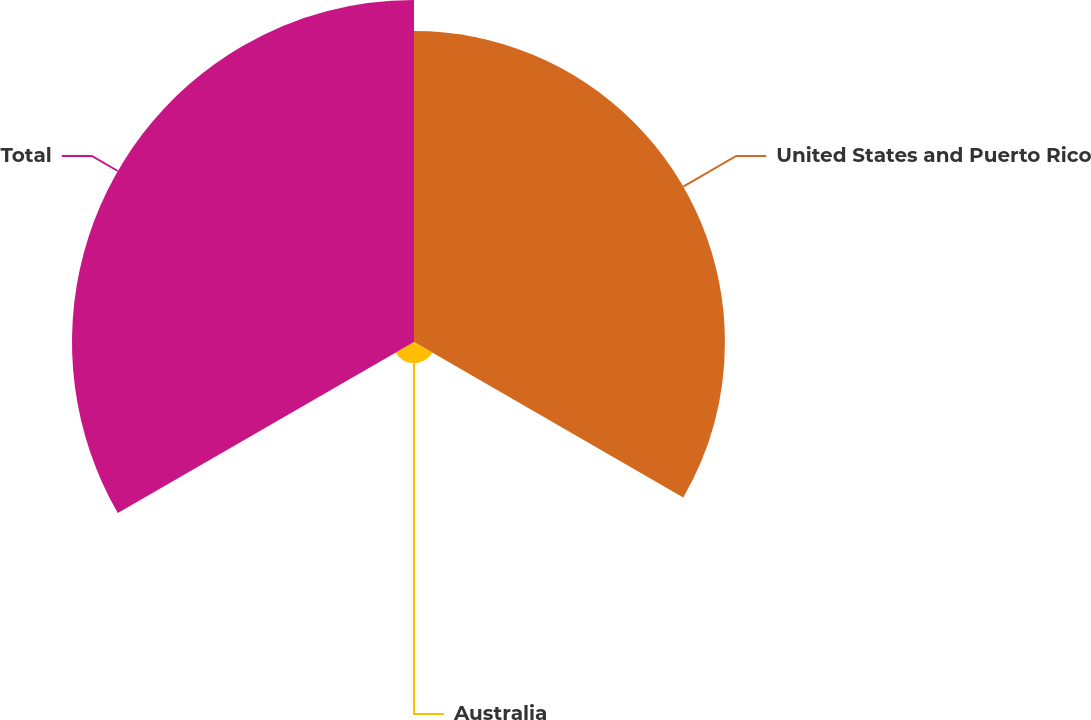<chart> <loc_0><loc_0><loc_500><loc_500><pie_chart><fcel>United States and Puerto Rico<fcel>Australia<fcel>Total<nl><fcel>46.12%<fcel>3.15%<fcel>50.73%<nl></chart> 